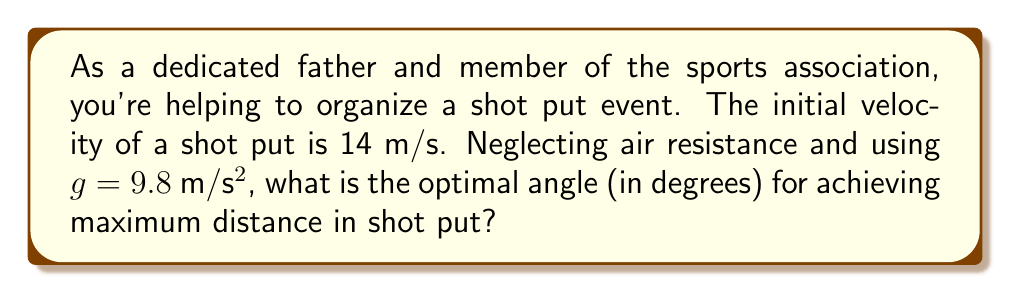Show me your answer to this math problem. To solve this problem, we'll follow these steps:

1) The optimal angle for maximum distance in projectile motion, neglecting air resistance, is always 45°. However, we need to prove this mathematically.

2) The range (R) of a projectile launched at an angle θ with initial velocity v is given by:

   $$R = \frac{v^2 \sin(2\theta)}{g}$$

3) To find the maximum range, we need to find the value of θ that maximizes this function. We can do this by taking the derivative with respect to θ and setting it to zero:

   $$\frac{dR}{d\theta} = \frac{v^2}{g} \cdot 2\cos(2\theta) = 0$$

4) This equation is satisfied when $\cos(2\theta) = 0$, which occurs when $2\theta = 90°$ or $\theta = 45°$.

5) We can confirm this is a maximum (not a minimum) by checking the second derivative is negative at this point.

6) Therefore, the optimal angle for maximum distance in shot put, neglecting air resistance, is always 45°, regardless of the initial velocity or the acceleration due to gravity.

7) In reality, due to factors like the height of release and air resistance, the optimal angle for shot put is slightly less than 45°, typically around 40-42°. However, for this idealized problem, we use 45°.
Answer: 45° 